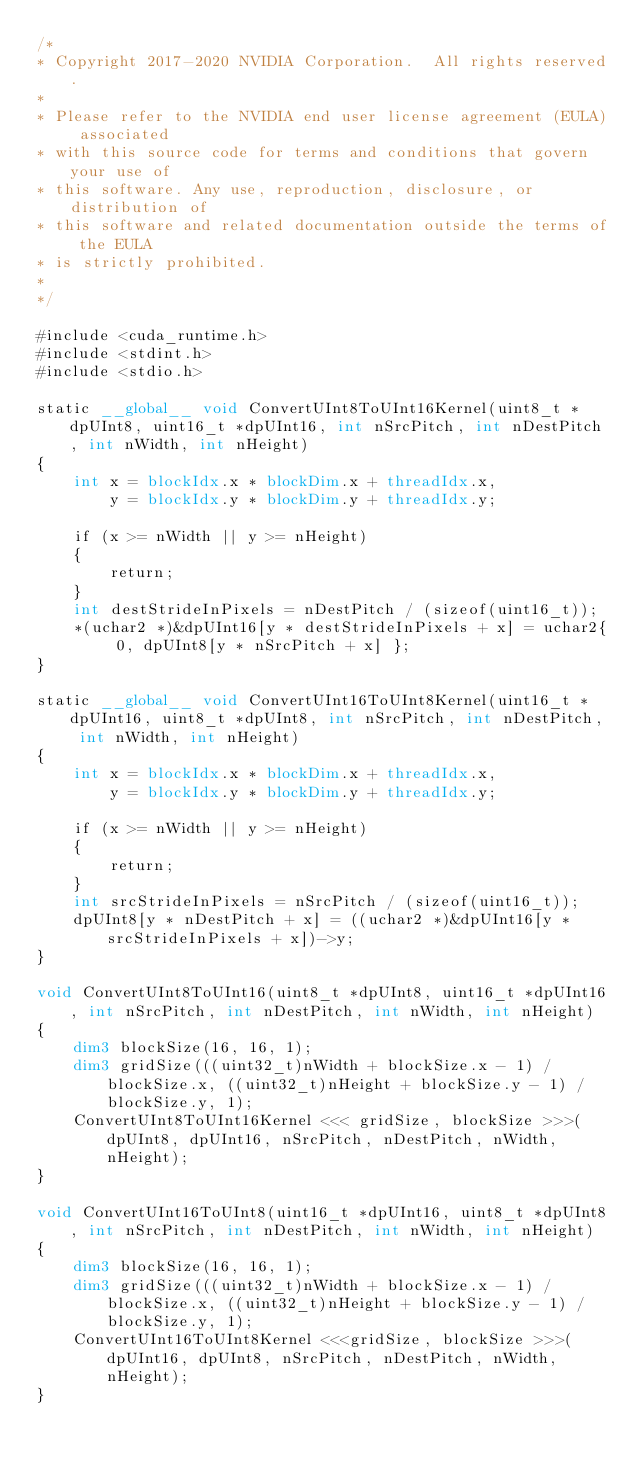<code> <loc_0><loc_0><loc_500><loc_500><_Cuda_>/*
* Copyright 2017-2020 NVIDIA Corporation.  All rights reserved.
*
* Please refer to the NVIDIA end user license agreement (EULA) associated
* with this source code for terms and conditions that govern your use of
* this software. Any use, reproduction, disclosure, or distribution of
* this software and related documentation outside the terms of the EULA
* is strictly prohibited.
*
*/

#include <cuda_runtime.h>
#include <stdint.h>
#include <stdio.h>

static __global__ void ConvertUInt8ToUInt16Kernel(uint8_t *dpUInt8, uint16_t *dpUInt16, int nSrcPitch, int nDestPitch, int nWidth, int nHeight)
{
    int x = blockIdx.x * blockDim.x + threadIdx.x,
        y = blockIdx.y * blockDim.y + threadIdx.y;

    if (x >= nWidth || y >= nHeight)
    {
        return;
    }
    int destStrideInPixels = nDestPitch / (sizeof(uint16_t));
    *(uchar2 *)&dpUInt16[y * destStrideInPixels + x] = uchar2{ 0, dpUInt8[y * nSrcPitch + x] };
}

static __global__ void ConvertUInt16ToUInt8Kernel(uint16_t *dpUInt16, uint8_t *dpUInt8, int nSrcPitch, int nDestPitch, int nWidth, int nHeight)
{
    int x = blockIdx.x * blockDim.x + threadIdx.x,
        y = blockIdx.y * blockDim.y + threadIdx.y;

    if (x >= nWidth || y >= nHeight)
    {
        return;
    }
    int srcStrideInPixels = nSrcPitch / (sizeof(uint16_t));
    dpUInt8[y * nDestPitch + x] = ((uchar2 *)&dpUInt16[y * srcStrideInPixels + x])->y;
}

void ConvertUInt8ToUInt16(uint8_t *dpUInt8, uint16_t *dpUInt16, int nSrcPitch, int nDestPitch, int nWidth, int nHeight)
{
    dim3 blockSize(16, 16, 1);
    dim3 gridSize(((uint32_t)nWidth + blockSize.x - 1) / blockSize.x, ((uint32_t)nHeight + blockSize.y - 1) / blockSize.y, 1);
    ConvertUInt8ToUInt16Kernel <<< gridSize, blockSize >>>(dpUInt8, dpUInt16, nSrcPitch, nDestPitch, nWidth, nHeight);
}

void ConvertUInt16ToUInt8(uint16_t *dpUInt16, uint8_t *dpUInt8, int nSrcPitch, int nDestPitch, int nWidth, int nHeight)
{
    dim3 blockSize(16, 16, 1);
    dim3 gridSize(((uint32_t)nWidth + blockSize.x - 1) / blockSize.x, ((uint32_t)nHeight + blockSize.y - 1) / blockSize.y, 1);
    ConvertUInt16ToUInt8Kernel <<<gridSize, blockSize >>>(dpUInt16, dpUInt8, nSrcPitch, nDestPitch, nWidth, nHeight);
}
</code> 